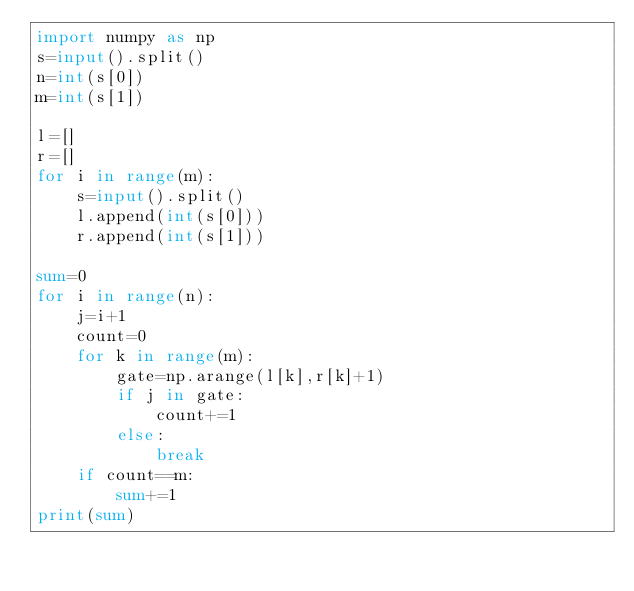Convert code to text. <code><loc_0><loc_0><loc_500><loc_500><_Python_>import numpy as np
s=input().split()
n=int(s[0])
m=int(s[1])

l=[]
r=[]
for i in range(m):
    s=input().split()
    l.append(int(s[0]))
    r.append(int(s[1]))

sum=0
for i in range(n):
    j=i+1
    count=0
    for k in range(m):
        gate=np.arange(l[k],r[k]+1)
        if j in gate:
            count+=1
        else:
            break
    if count==m:
        sum+=1
print(sum)
</code> 